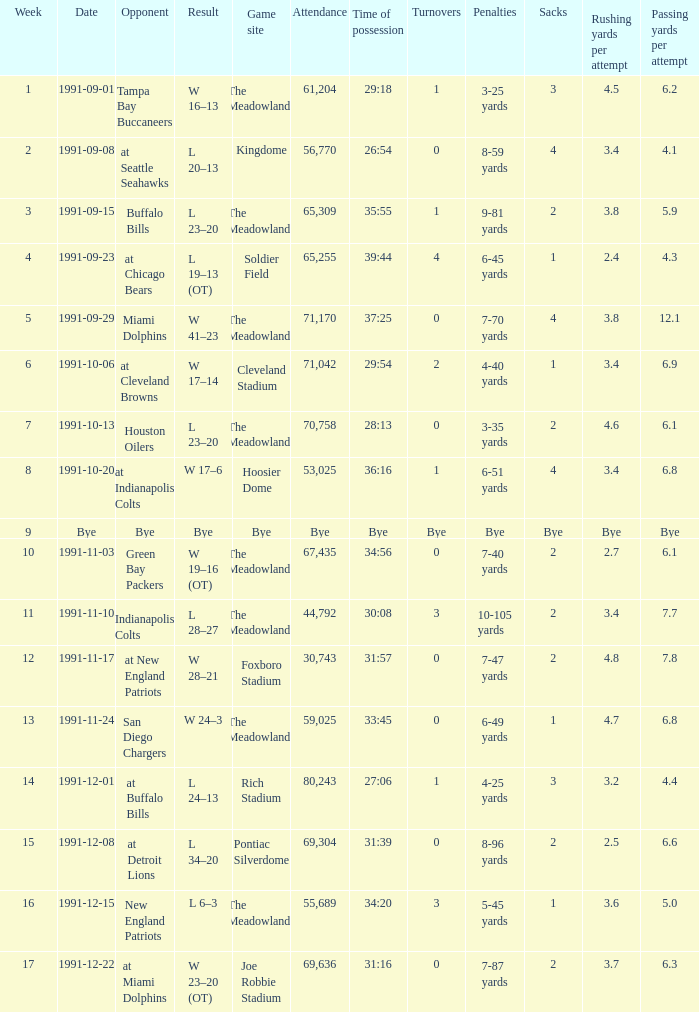What was the Attendance in Week 17? 69636.0. 